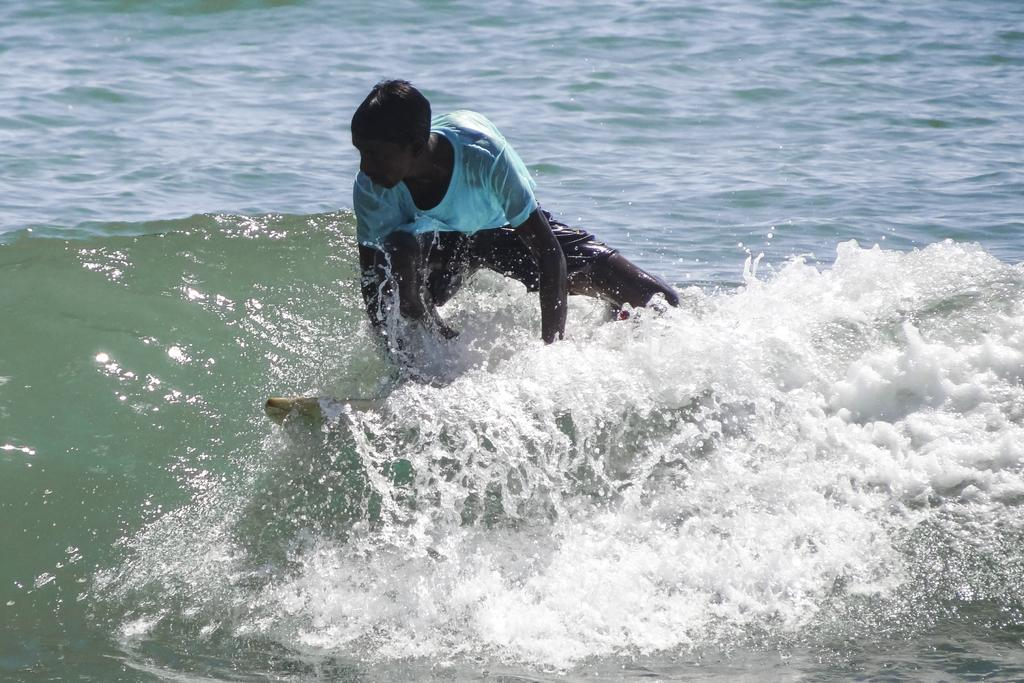What is the main subject of the image? There is a person in the image. What activity is the person engaged in? The person is surfing on the water. Where is the person located in the image? The person is in the center of the image. What type of expansion can be seen in the image? There is no expansion visible in the image. What season is depicted in the image? The provided facts do not mention any specific season, so it cannot be determined from the image. 